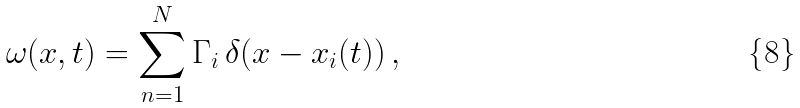<formula> <loc_0><loc_0><loc_500><loc_500>\omega ( x , t ) = \sum _ { n = 1 } ^ { N } \Gamma _ { i } \, \delta ( x - x _ { i } ( t ) ) \, ,</formula> 